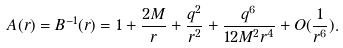<formula> <loc_0><loc_0><loc_500><loc_500>A ( r ) = B ^ { - 1 } ( r ) = 1 + \frac { 2 M } { r } + \frac { q ^ { 2 } } { r ^ { 2 } } + \frac { q ^ { 6 } } { 1 2 M ^ { 2 } r ^ { 4 } } + O ( \frac { 1 } { r ^ { 6 } } ) .</formula> 